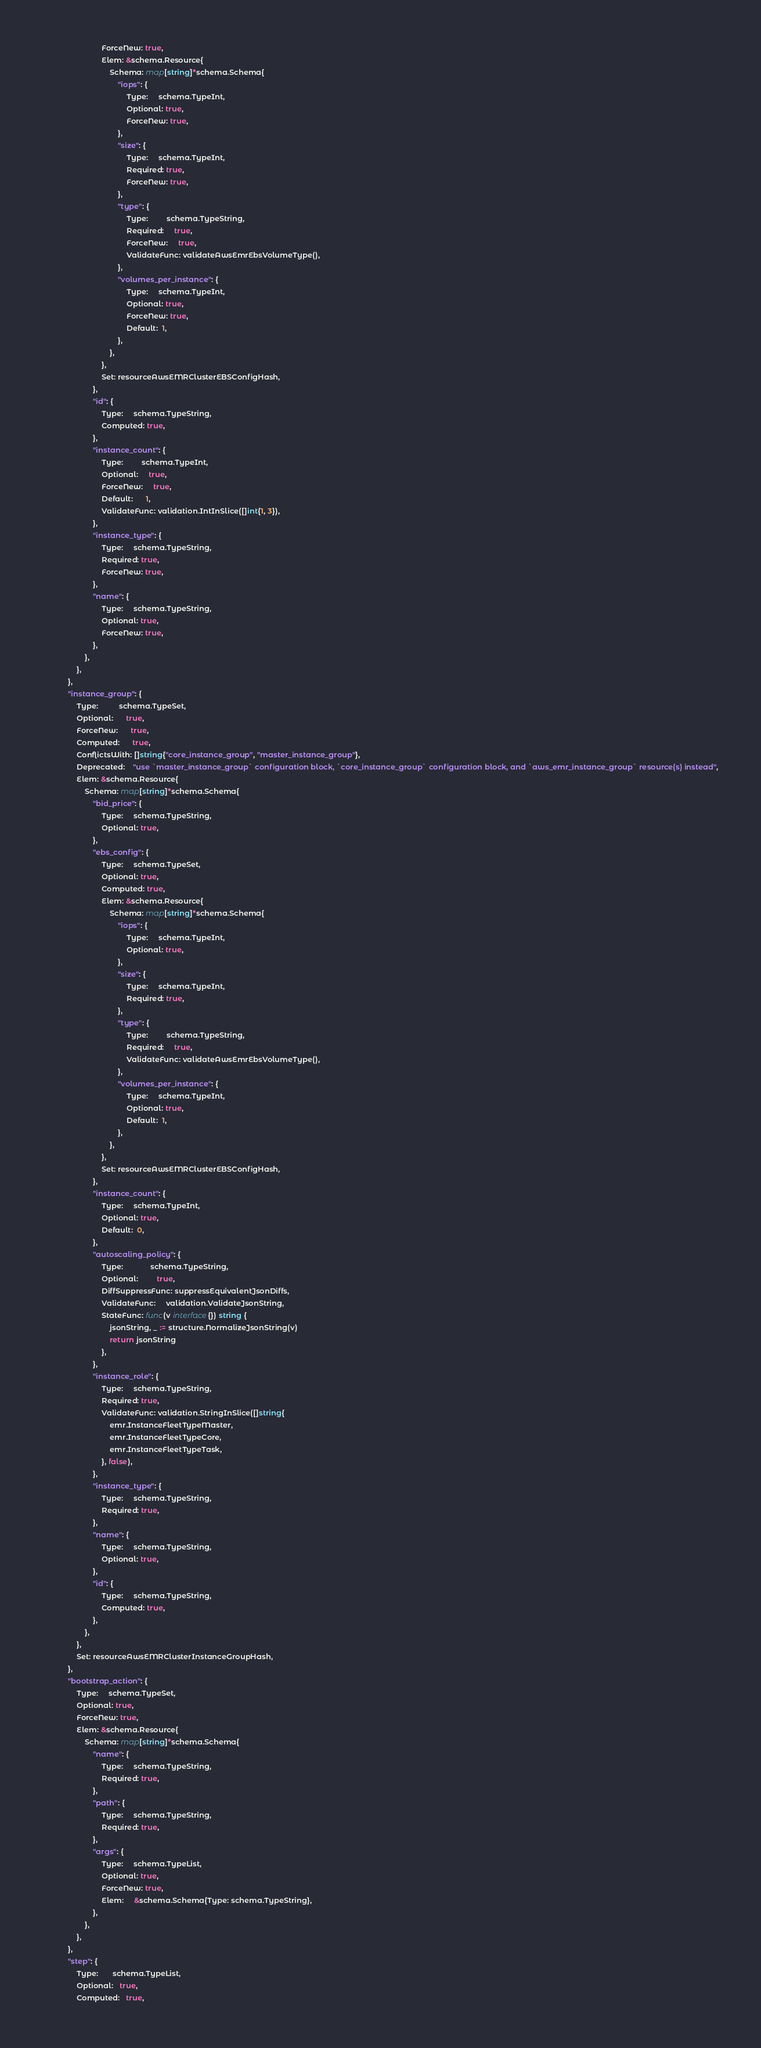Convert code to text. <code><loc_0><loc_0><loc_500><loc_500><_Go_>							ForceNew: true,
							Elem: &schema.Resource{
								Schema: map[string]*schema.Schema{
									"iops": {
										Type:     schema.TypeInt,
										Optional: true,
										ForceNew: true,
									},
									"size": {
										Type:     schema.TypeInt,
										Required: true,
										ForceNew: true,
									},
									"type": {
										Type:         schema.TypeString,
										Required:     true,
										ForceNew:     true,
										ValidateFunc: validateAwsEmrEbsVolumeType(),
									},
									"volumes_per_instance": {
										Type:     schema.TypeInt,
										Optional: true,
										ForceNew: true,
										Default:  1,
									},
								},
							},
							Set: resourceAwsEMRClusterEBSConfigHash,
						},
						"id": {
							Type:     schema.TypeString,
							Computed: true,
						},
						"instance_count": {
							Type:         schema.TypeInt,
							Optional:     true,
							ForceNew:     true,
							Default:      1,
							ValidateFunc: validation.IntInSlice([]int{1, 3}),
						},
						"instance_type": {
							Type:     schema.TypeString,
							Required: true,
							ForceNew: true,
						},
						"name": {
							Type:     schema.TypeString,
							Optional: true,
							ForceNew: true,
						},
					},
				},
			},
			"instance_group": {
				Type:          schema.TypeSet,
				Optional:      true,
				ForceNew:      true,
				Computed:      true,
				ConflictsWith: []string{"core_instance_group", "master_instance_group"},
				Deprecated:    "use `master_instance_group` configuration block, `core_instance_group` configuration block, and `aws_emr_instance_group` resource(s) instead",
				Elem: &schema.Resource{
					Schema: map[string]*schema.Schema{
						"bid_price": {
							Type:     schema.TypeString,
							Optional: true,
						},
						"ebs_config": {
							Type:     schema.TypeSet,
							Optional: true,
							Computed: true,
							Elem: &schema.Resource{
								Schema: map[string]*schema.Schema{
									"iops": {
										Type:     schema.TypeInt,
										Optional: true,
									},
									"size": {
										Type:     schema.TypeInt,
										Required: true,
									},
									"type": {
										Type:         schema.TypeString,
										Required:     true,
										ValidateFunc: validateAwsEmrEbsVolumeType(),
									},
									"volumes_per_instance": {
										Type:     schema.TypeInt,
										Optional: true,
										Default:  1,
									},
								},
							},
							Set: resourceAwsEMRClusterEBSConfigHash,
						},
						"instance_count": {
							Type:     schema.TypeInt,
							Optional: true,
							Default:  0,
						},
						"autoscaling_policy": {
							Type:             schema.TypeString,
							Optional:         true,
							DiffSuppressFunc: suppressEquivalentJsonDiffs,
							ValidateFunc:     validation.ValidateJsonString,
							StateFunc: func(v interface{}) string {
								jsonString, _ := structure.NormalizeJsonString(v)
								return jsonString
							},
						},
						"instance_role": {
							Type:     schema.TypeString,
							Required: true,
							ValidateFunc: validation.StringInSlice([]string{
								emr.InstanceFleetTypeMaster,
								emr.InstanceFleetTypeCore,
								emr.InstanceFleetTypeTask,
							}, false),
						},
						"instance_type": {
							Type:     schema.TypeString,
							Required: true,
						},
						"name": {
							Type:     schema.TypeString,
							Optional: true,
						},
						"id": {
							Type:     schema.TypeString,
							Computed: true,
						},
					},
				},
				Set: resourceAwsEMRClusterInstanceGroupHash,
			},
			"bootstrap_action": {
				Type:     schema.TypeSet,
				Optional: true,
				ForceNew: true,
				Elem: &schema.Resource{
					Schema: map[string]*schema.Schema{
						"name": {
							Type:     schema.TypeString,
							Required: true,
						},
						"path": {
							Type:     schema.TypeString,
							Required: true,
						},
						"args": {
							Type:     schema.TypeList,
							Optional: true,
							ForceNew: true,
							Elem:     &schema.Schema{Type: schema.TypeString},
						},
					},
				},
			},
			"step": {
				Type:       schema.TypeList,
				Optional:   true,
				Computed:   true,</code> 